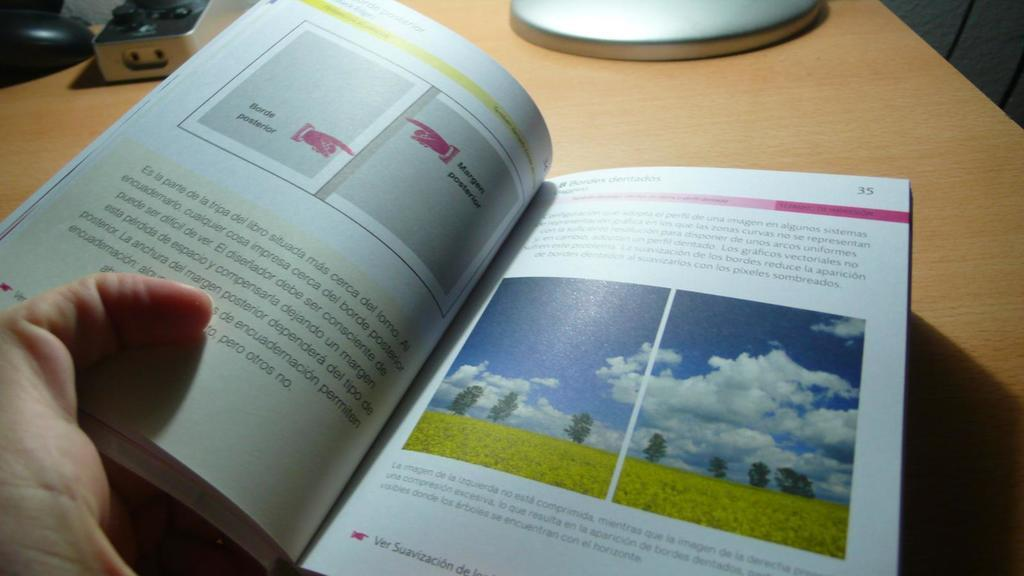<image>
Provide a brief description of the given image. A booklet is opened to page number 35. 